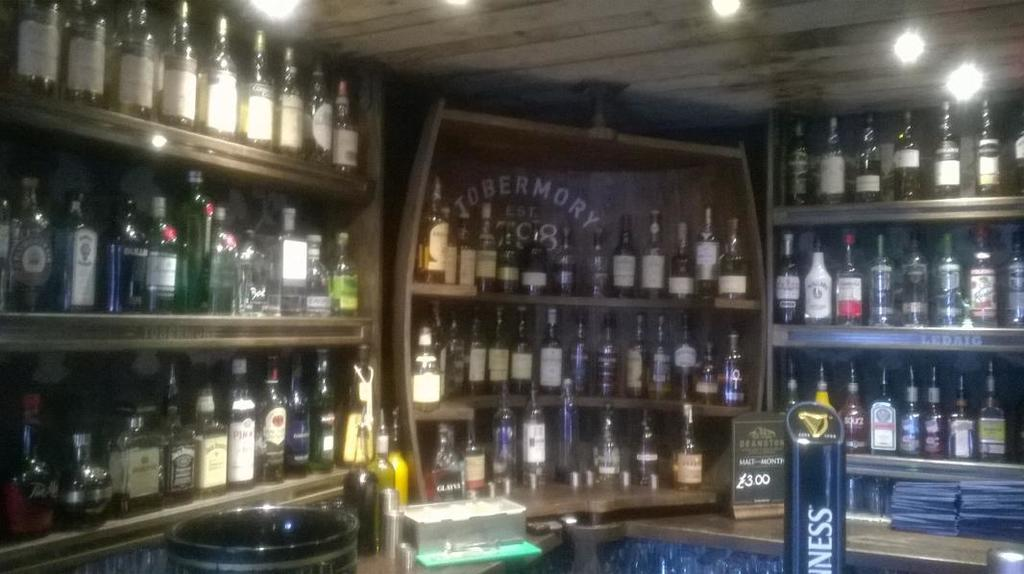What is the main subject of the image? The main subject of the image is a group of wine bottles. Where are the wine bottles placed in the image? The wine bottles are placed on a stair table. What type of territory is being claimed by the wine bottles in the image? There is no indication of territory being claimed in the image; it simply shows a group of wine bottles on a stair table. 